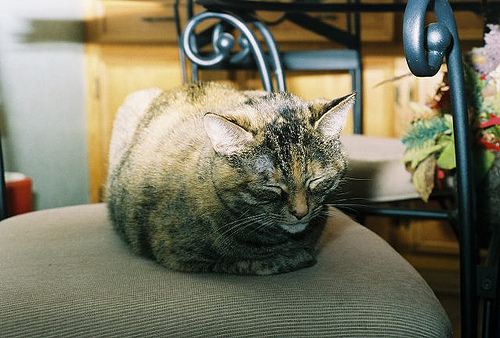<image>
Is the cat above the chair? No. The cat is not positioned above the chair. The vertical arrangement shows a different relationship. Where is the kitty in relation to the chair? Is it on the chair? Yes. Looking at the image, I can see the kitty is positioned on top of the chair, with the chair providing support. Is there a drawer in front of the cat? No. The drawer is not in front of the cat. The spatial positioning shows a different relationship between these objects. 